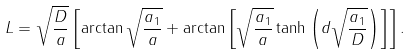Convert formula to latex. <formula><loc_0><loc_0><loc_500><loc_500>L = \sqrt { \frac { D } { a } } \left [ \arctan \sqrt { \frac { a _ { 1 } } { a } } + \arctan \left [ \sqrt { \frac { a _ { 1 } } { a } } \tanh \left ( d \sqrt { \frac { a _ { 1 } } { D } } \right ) \right ] \right ] .</formula> 